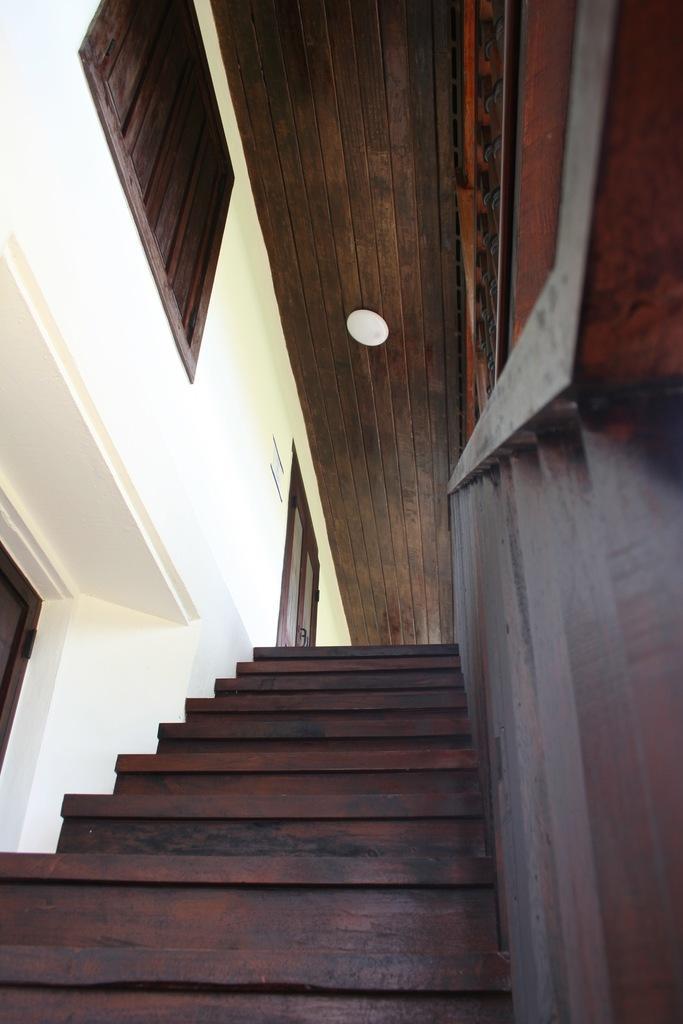Please provide a concise description of this image. In this image we can see staircase, wooden railing, roof and walls. 